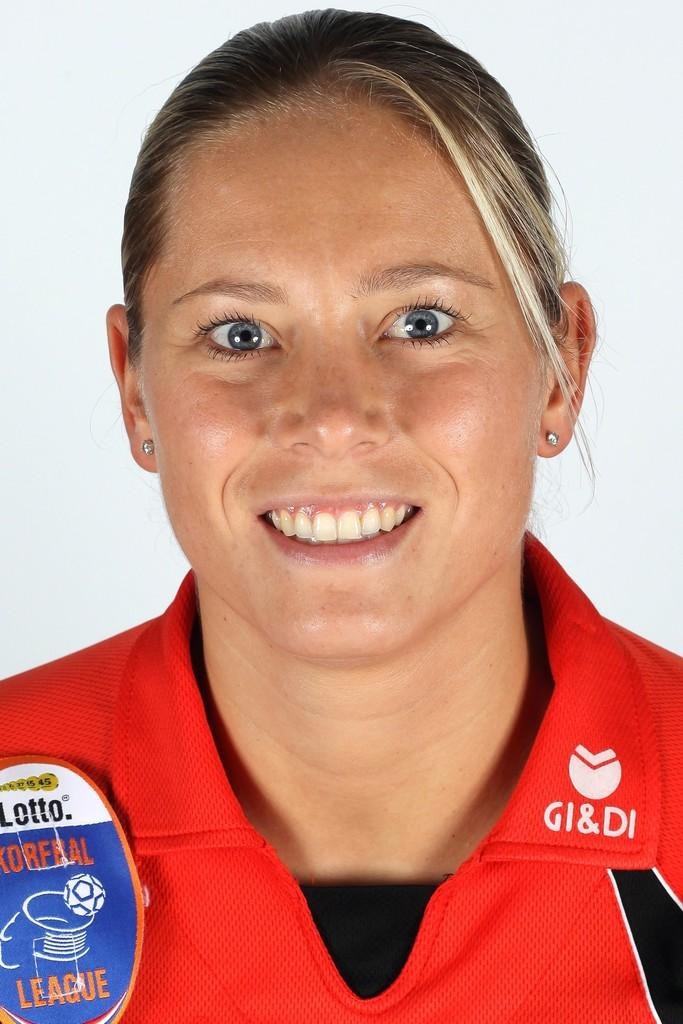<image>
Render a clear and concise summary of the photo. a lady with Lotto written on her shirt 